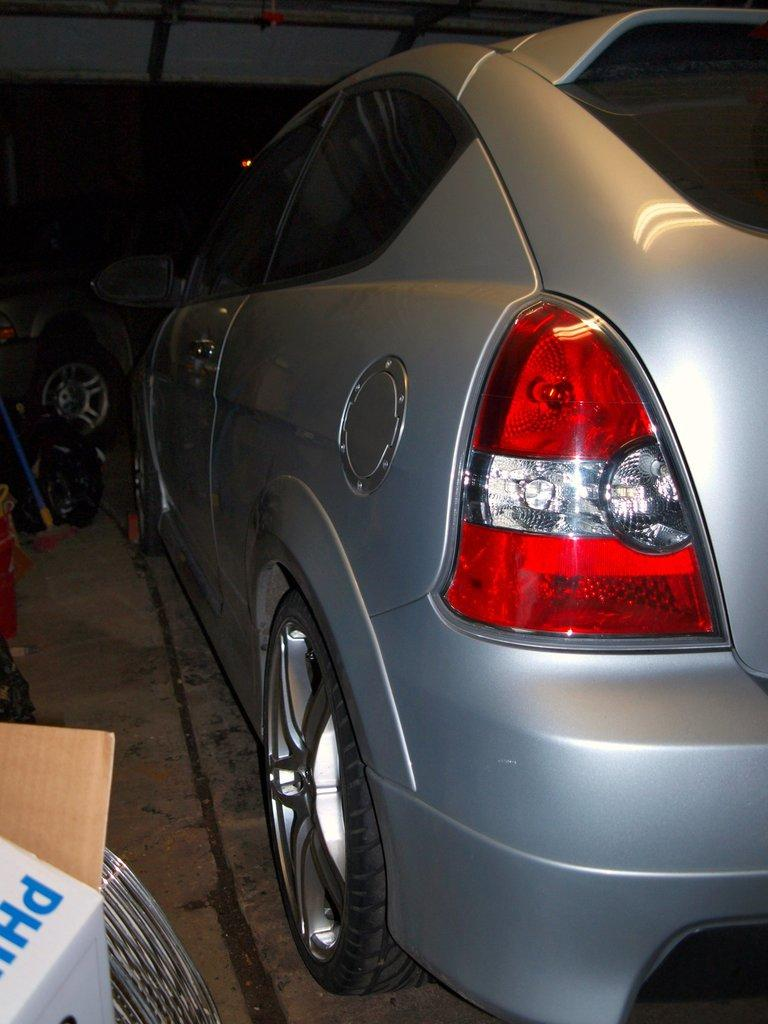What is the main subject of the image? The main subject of the image is a car. Can you describe the car's position in the image? The car is on the surface in the image. What else can be seen on the left side, bottom of the image? There is a box in that location. What is visible in the background of the image? The background of the image includes wheels. What type of wall can be seen in the image? There is no wall present in the image. Do you believe the car is capable of taking photographs in the image? The image does not show the car having any camera or photography-related features. 